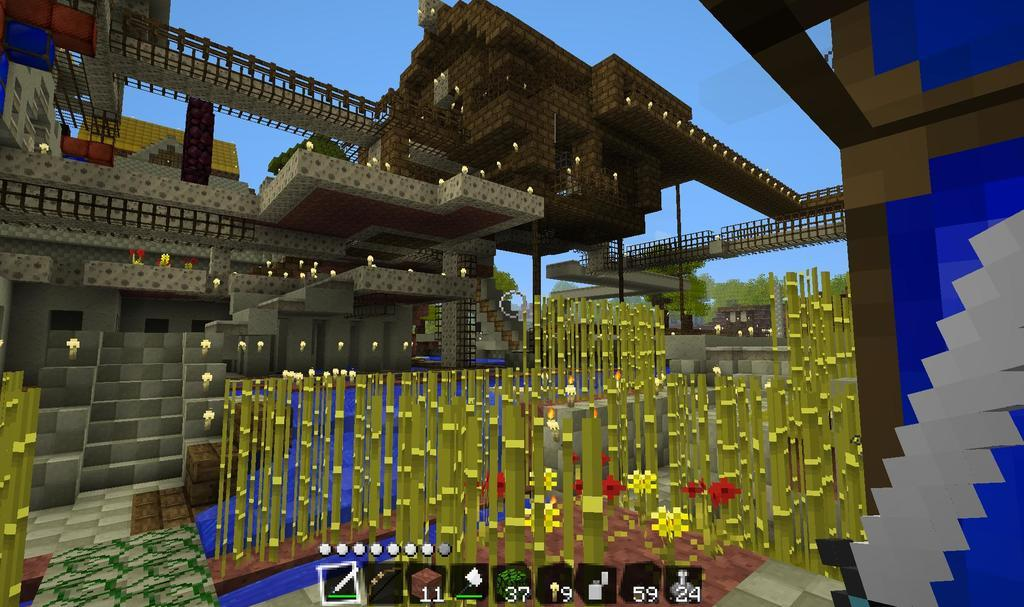What type of image is being depicted? The image appears to be a computer game. What is the main structure in the image? There is a building in the middle of the image. What is visible at the top of the image? The sky is visible at the top of the image. What type of music can be heard playing in the background of the image? There is no music present in the image, as it is a still image of a computer game. 